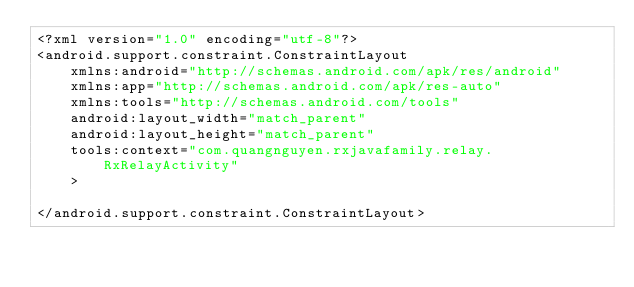<code> <loc_0><loc_0><loc_500><loc_500><_XML_><?xml version="1.0" encoding="utf-8"?>
<android.support.constraint.ConstraintLayout
    xmlns:android="http://schemas.android.com/apk/res/android"
    xmlns:app="http://schemas.android.com/apk/res-auto"
    xmlns:tools="http://schemas.android.com/tools"
    android:layout_width="match_parent"
    android:layout_height="match_parent"
    tools:context="com.quangnguyen.rxjavafamily.relay.RxRelayActivity"
    >

</android.support.constraint.ConstraintLayout>
</code> 